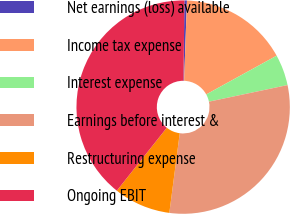Convert chart. <chart><loc_0><loc_0><loc_500><loc_500><pie_chart><fcel>Net earnings (loss) available<fcel>Income tax expense<fcel>Interest expense<fcel>Earnings before interest &<fcel>Restructuring expense<fcel>Ongoing EBIT<nl><fcel>0.38%<fcel>16.43%<fcel>4.69%<fcel>30.38%<fcel>8.61%<fcel>39.51%<nl></chart> 